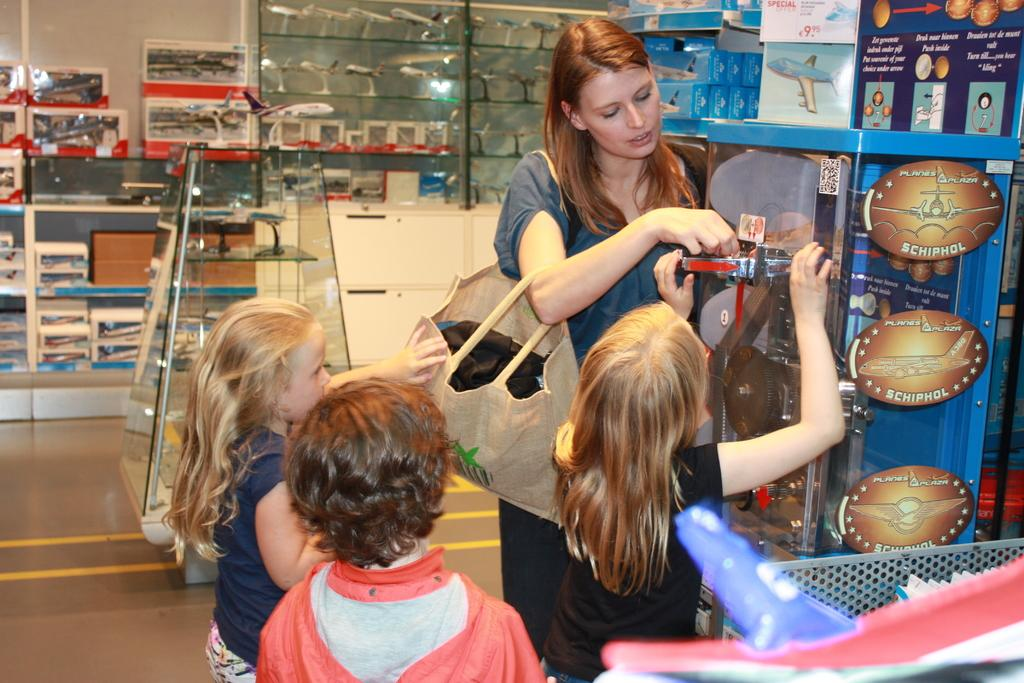Who is the main subject in the image? There is a woman in the image. What is the kid in front of the woman doing? The kid is holding an object in front of them. How many other kids are present in the image? There are two other kids behind the woman and the first kid. What can be seen in the background of the image? There are toys in the background of the image. What type of pies is the woman baking in the image? There is no indication in the image that the woman is baking pies, so it cannot be determined from the picture. 